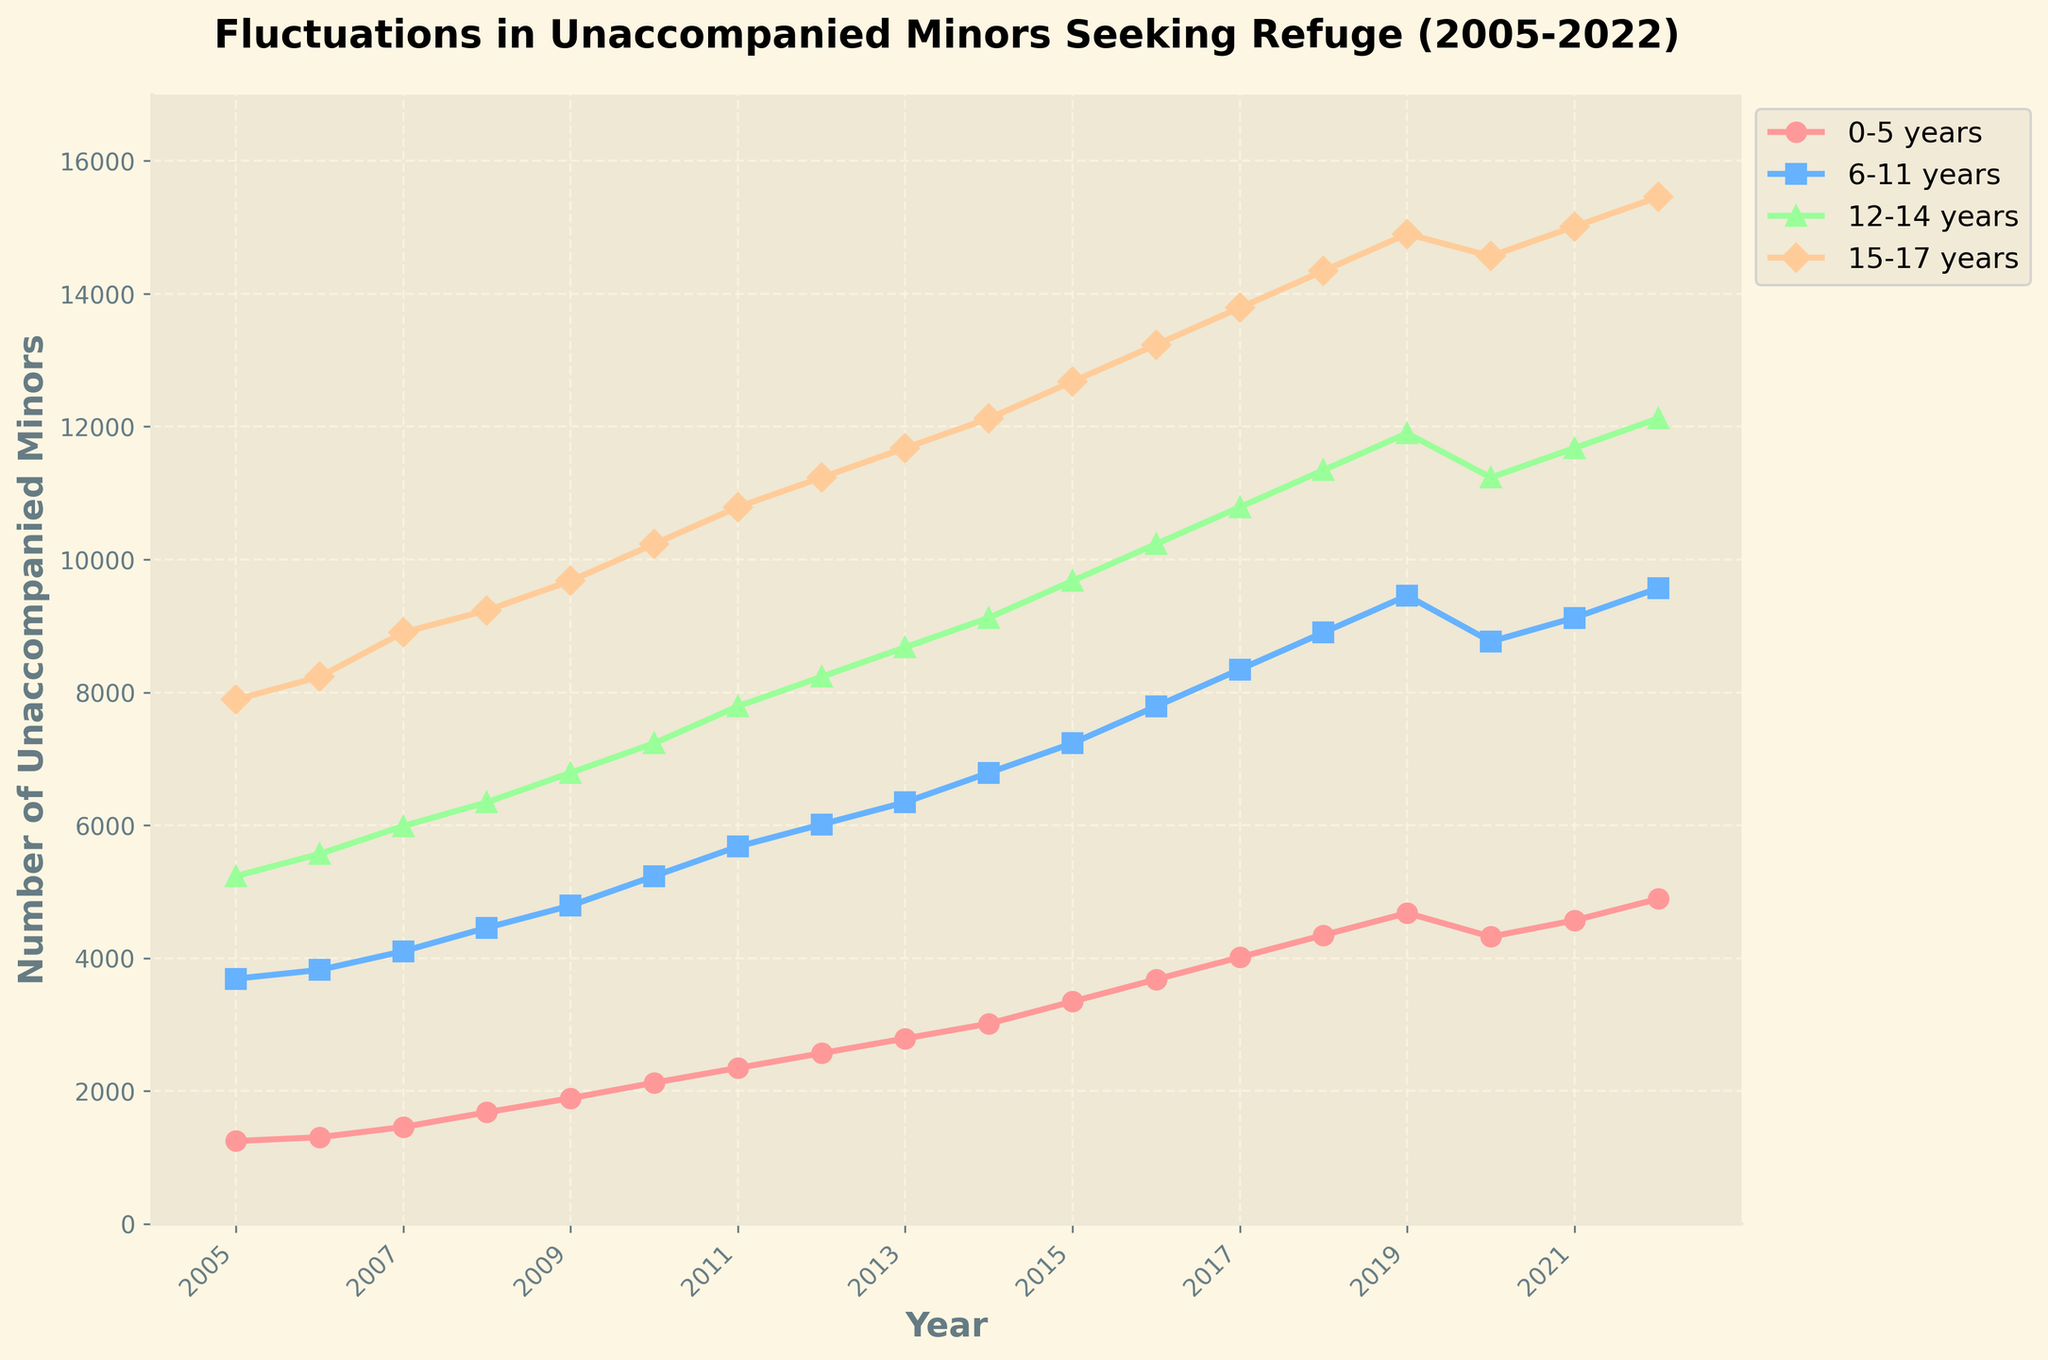What is the overall trend in the number of unaccompanied minors seeking refuge for the 15-17 years age group from 2005 to 2022? The number of unaccompanied minors in the 15-17 years age group has consistently increased from 7,890 in 2005 to 15,456 in 2022. There are no noticeable drops, just a slight decline between 2019 and 2020, but the overall trend is upward.
Answer: The trend is increasing Which age group experienced the largest growth from 2005 to 2022? To find the largest growth, subtract the 2005 values from the 2022 values for each age group: 
0-5 years: 4890 - 1245 = 3,645
6-11 years: 9567 - 3689 = 5,878
12-14 years: 12123 - 5234 = 6,889
15-17 years: 15456 - 7890 = 7,566. 
The group 15-17 years shows the largest growth.
Answer: 15-17 years In which year did the number of unaccompanied minors aged 12-14 years first exceed 10,000? Observing the trend for the 12-14 years age group, the number first exceeds 10,000 in 2016, going from 9,678 in 2015 to 10,234 in 2016.
Answer: 2016 Between which two consecutive years did the 0-5 years age group see the most significant increase? Calculating the differences for each consecutive year for the 0-5 years age group:
2006-2005: 1302 - 1245 = 57
2007-2006: 1456 - 1302 = 154
2008-2007: 1678 - 1456 = 222
2009-2008: 1890 - 1678 = 212
2010-2009: 2123 - 1890 = 233
2011-2010: 2345 - 2123 = 222
2012-2011: 2567 - 2345 = 222
2013-2012: 2789 - 2567 = 222
2014-2013: 3012 - 2789 = 223
2015-2014: 3345 - 3012 = 333
2016-2015: 3678 - 3345 = 333
2017-2016: 4012 - 3678 = 334
2018-2017: 4345 - 4012 = 333
2019-2018: 4678 - 4345 = 333
2020-2019: 4321 - 4678 = -357
2021-2020: 4567 - 4321 = 246
2022-2021: 4890 - 4567 = 323. 
The most significant increase is from 2013 to 2014.
Answer: 2013 to 2014 What is the difference in the number of unaccompanied minors between the 6-11 years age group and 0-5 years age group in 2022? Subtract the number of unaccompanied minors in the 0-5 years age group from the 6-11 years age group for the year 2022: 9567 - 4890 = 4,677.
Answer: 4677 What is the average number of unaccompanied minors aged 12-14 years from 2016 to 2020? Add the number of unaccompanied minors for each year from 2016 to 2020 for the 12-14 years age group: 10234 + 10789 + 11345 + 11901 + 11234 = 55503. Then divide by 5: 55503 / 5 = 11,100.6.
Answer: 11,100.6 In what year did the 6-11 years age group see the least number of unaccompanied minors, and what was the value? The least number of unaccompanied minors in the 6-11 years age group is in 2005, where the number is 3,689.
Answer: 2005, 3689 How did the 0-5 years age group change from 2019 to 2020 compared to the 12-14 years age group? The 0-5 years age group decreased from 4,678 in 2019 to 4,321 in 2020, which is a decrease of 357. The 12-14 years age group decreased from 11,901 in 2019 to 11,234 in 2020, which is a decrease of 667.
Answer: Both decreased, with the 12-14 years group having a larger decline Which age group experienced nearly stable numbers from 2020 to 2021, and what does this stability indicate? The 0-5 years age group shows relative stability, going from 4,321 in 2020 to 4,567 in 2021, a small increase of 246. This stability might indicate efforts that were relatively successful in maintaining the welfare or situation of younger unaccompanied minors during this period.
Answer: 0-5 years 